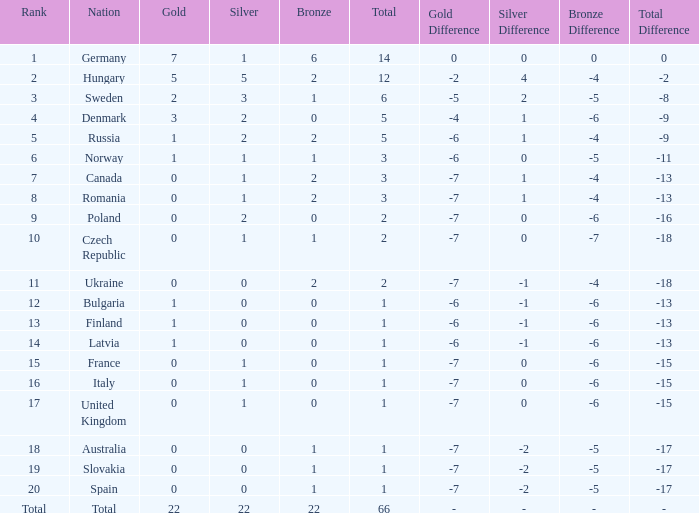What is the fewest number of silver medals won by Canada with fewer than 3 total medals? None. 